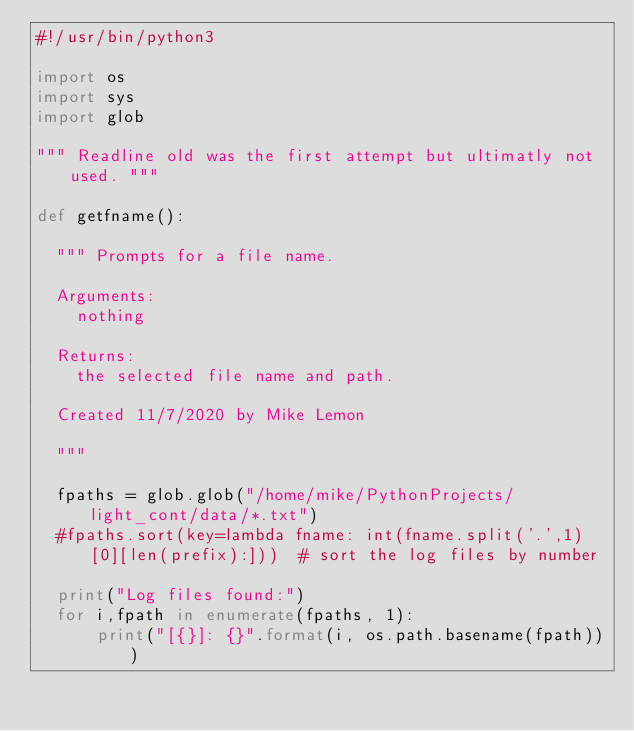<code> <loc_0><loc_0><loc_500><loc_500><_Python_>#!/usr/bin/python3

import os
import sys
import glob
	
""" Readline old was the first attempt but ultimatly not used. """

def getfname():
	
	""" Prompts for a file name.
	
	Arguments: 
		nothing
	
	Returns:
		the selected file name and path.
		
	Created 11/7/2020 by Mike Lemon
	
	"""

	fpaths = glob.glob("/home/mike/PythonProjects/light_cont/data/*.txt")
	#fpaths.sort(key=lambda fname: int(fname.split('.',1)[0][len(prefix):]))  # sort the log files by number

	print("Log files found:")
	for i,fpath in enumerate(fpaths, 1):
			print("[{}]: {}".format(i, os.path.basename(fpath)))
</code> 